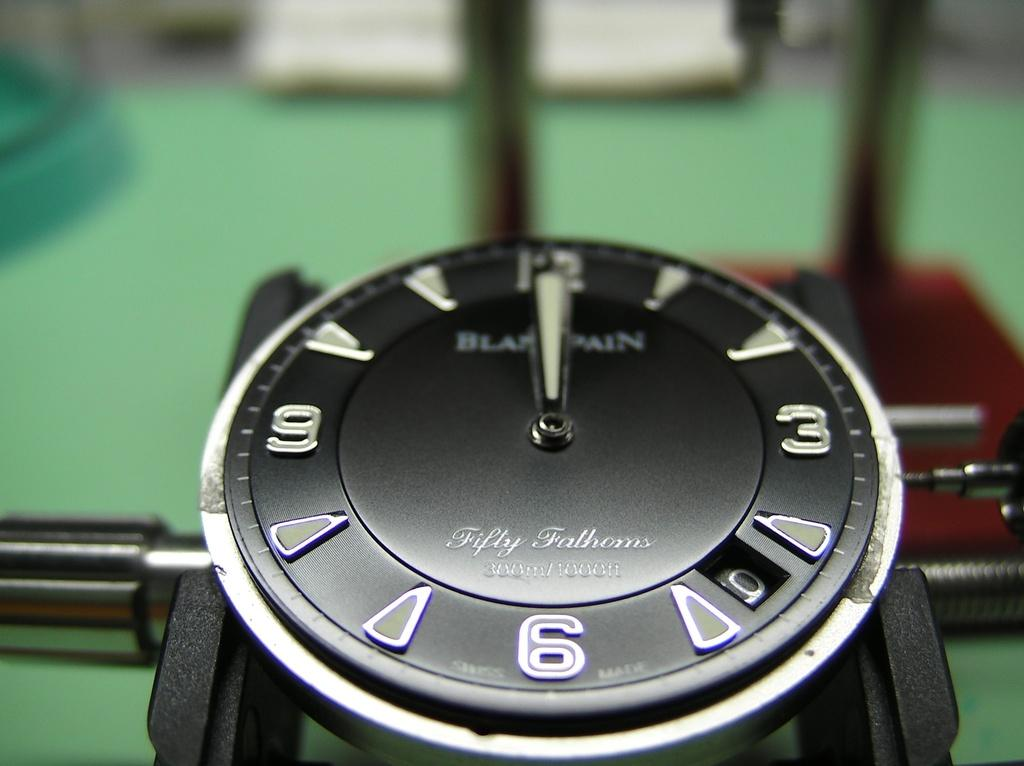<image>
Give a short and clear explanation of the subsequent image. Black Fifty Fathoms 300 meter underwater Swiss watch. 